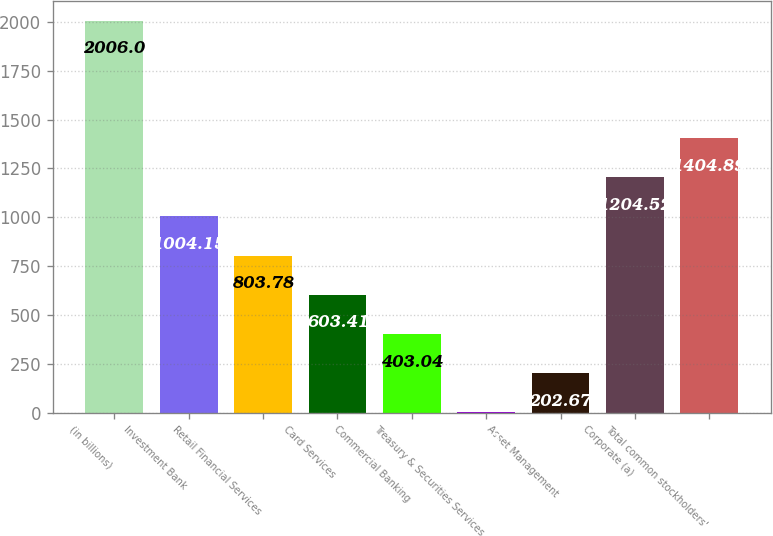Convert chart. <chart><loc_0><loc_0><loc_500><loc_500><bar_chart><fcel>(in billions)<fcel>Investment Bank<fcel>Retail Financial Services<fcel>Card Services<fcel>Commercial Banking<fcel>Treasury & Securities Services<fcel>Asset Management<fcel>Corporate (a)<fcel>Total common stockholders'<nl><fcel>2006<fcel>1004.15<fcel>803.78<fcel>603.41<fcel>403.04<fcel>2.3<fcel>202.67<fcel>1204.52<fcel>1404.89<nl></chart> 